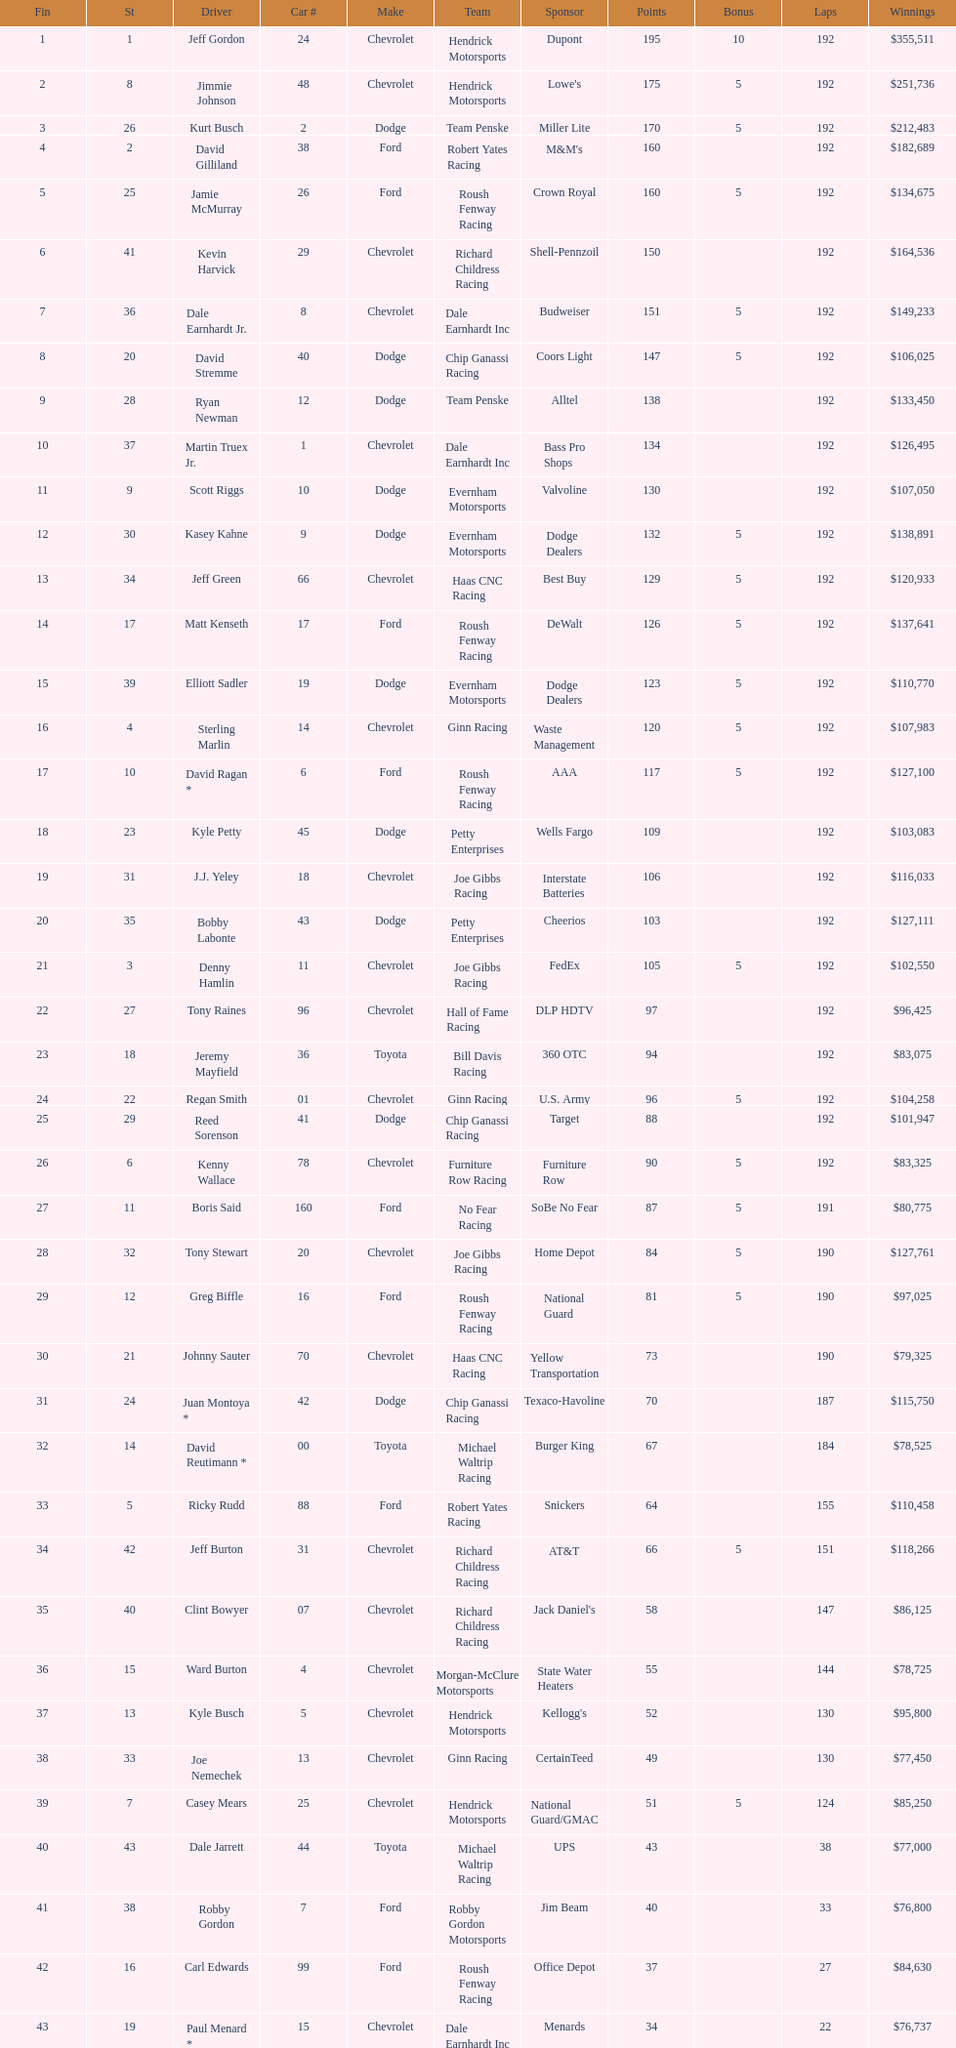How many drivers earned no bonus for this race? 23. 